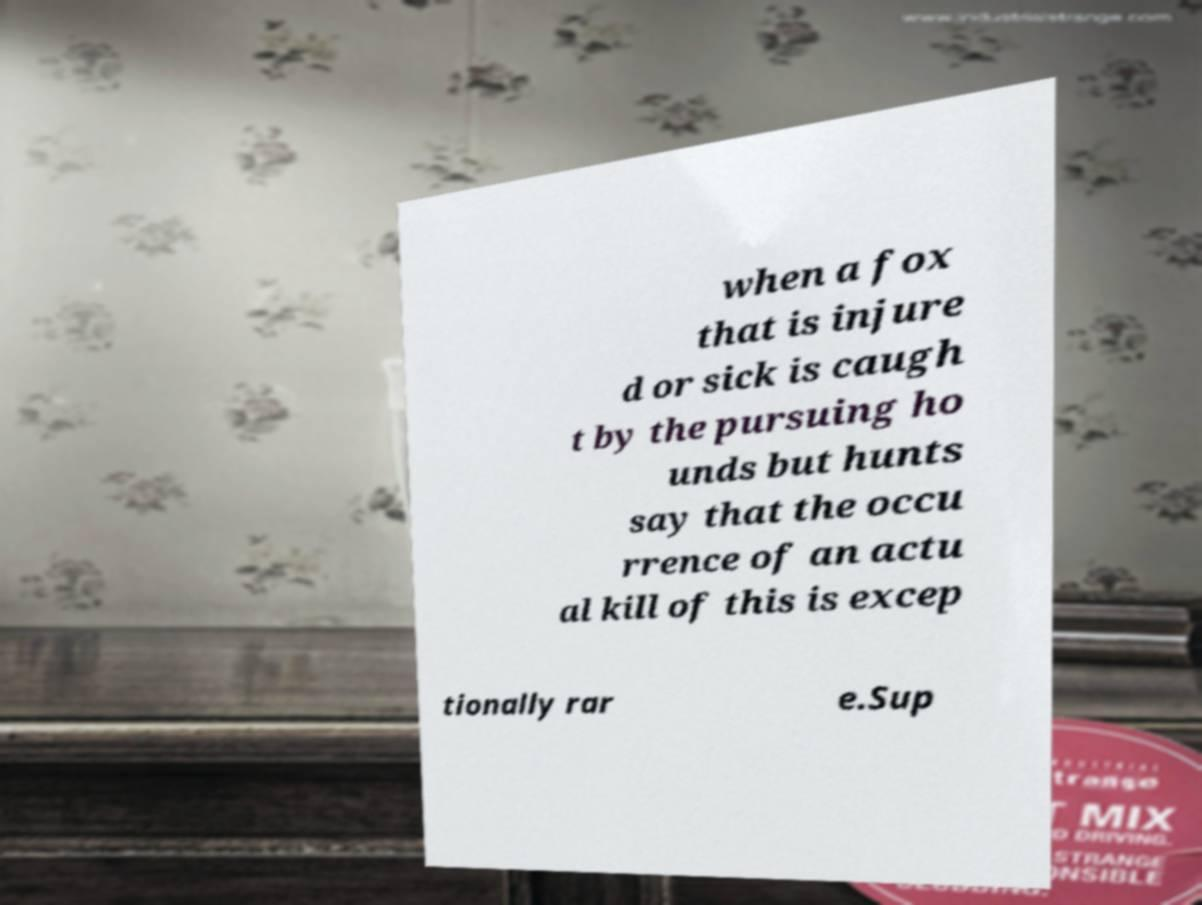What messages or text are displayed in this image? I need them in a readable, typed format. when a fox that is injure d or sick is caugh t by the pursuing ho unds but hunts say that the occu rrence of an actu al kill of this is excep tionally rar e.Sup 